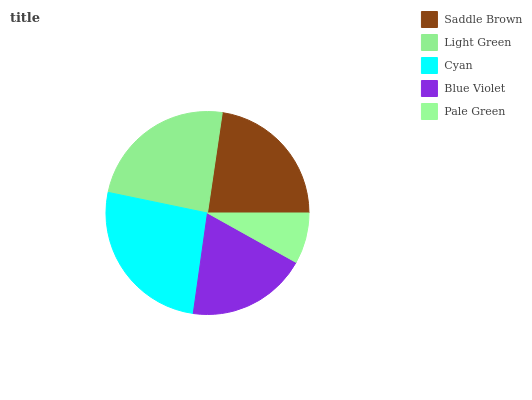Is Pale Green the minimum?
Answer yes or no. Yes. Is Cyan the maximum?
Answer yes or no. Yes. Is Light Green the minimum?
Answer yes or no. No. Is Light Green the maximum?
Answer yes or no. No. Is Light Green greater than Saddle Brown?
Answer yes or no. Yes. Is Saddle Brown less than Light Green?
Answer yes or no. Yes. Is Saddle Brown greater than Light Green?
Answer yes or no. No. Is Light Green less than Saddle Brown?
Answer yes or no. No. Is Saddle Brown the high median?
Answer yes or no. Yes. Is Saddle Brown the low median?
Answer yes or no. Yes. Is Pale Green the high median?
Answer yes or no. No. Is Light Green the low median?
Answer yes or no. No. 